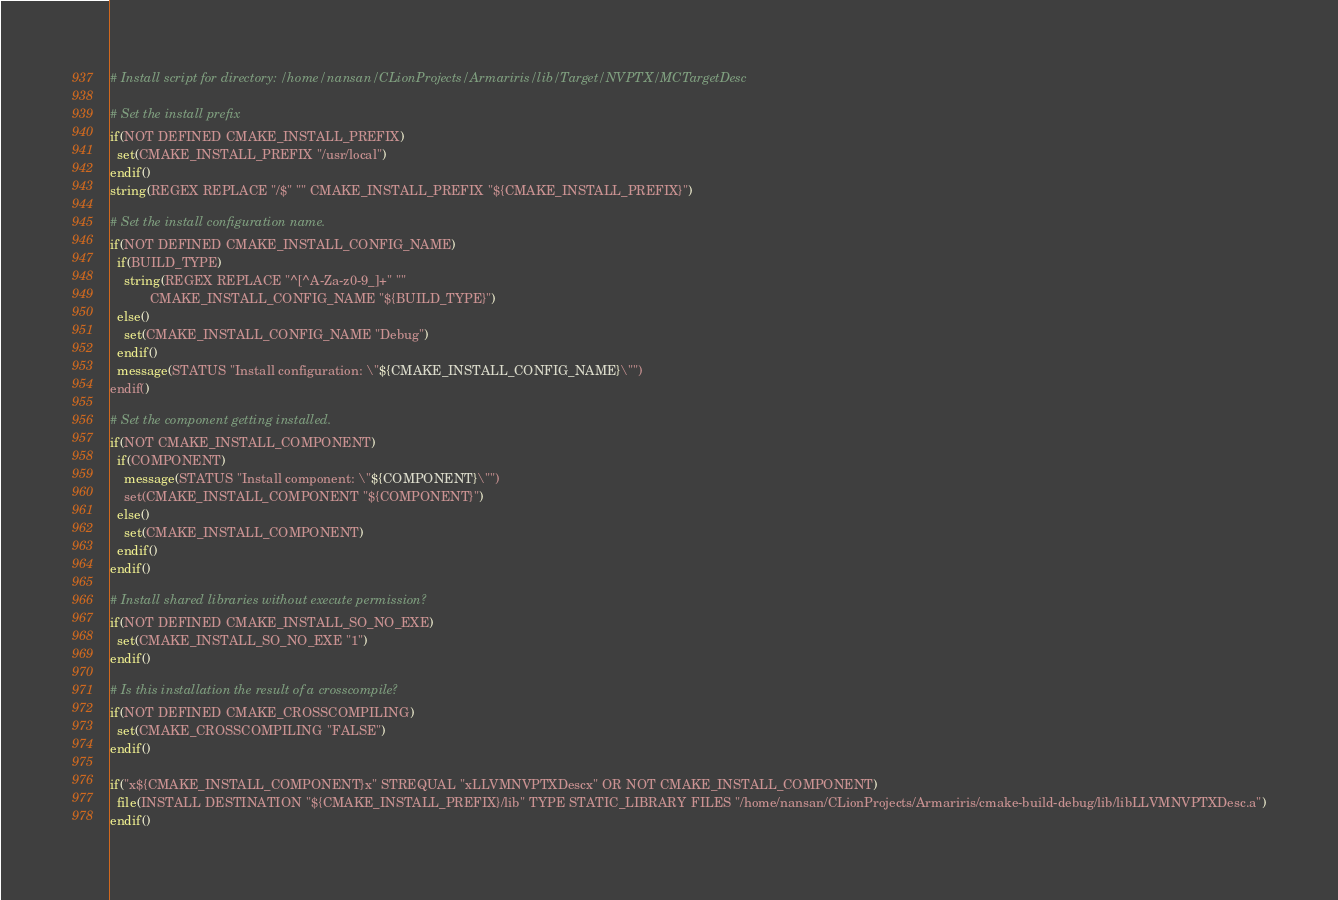<code> <loc_0><loc_0><loc_500><loc_500><_CMake_># Install script for directory: /home/nansan/CLionProjects/Armariris/lib/Target/NVPTX/MCTargetDesc

# Set the install prefix
if(NOT DEFINED CMAKE_INSTALL_PREFIX)
  set(CMAKE_INSTALL_PREFIX "/usr/local")
endif()
string(REGEX REPLACE "/$" "" CMAKE_INSTALL_PREFIX "${CMAKE_INSTALL_PREFIX}")

# Set the install configuration name.
if(NOT DEFINED CMAKE_INSTALL_CONFIG_NAME)
  if(BUILD_TYPE)
    string(REGEX REPLACE "^[^A-Za-z0-9_]+" ""
           CMAKE_INSTALL_CONFIG_NAME "${BUILD_TYPE}")
  else()
    set(CMAKE_INSTALL_CONFIG_NAME "Debug")
  endif()
  message(STATUS "Install configuration: \"${CMAKE_INSTALL_CONFIG_NAME}\"")
endif()

# Set the component getting installed.
if(NOT CMAKE_INSTALL_COMPONENT)
  if(COMPONENT)
    message(STATUS "Install component: \"${COMPONENT}\"")
    set(CMAKE_INSTALL_COMPONENT "${COMPONENT}")
  else()
    set(CMAKE_INSTALL_COMPONENT)
  endif()
endif()

# Install shared libraries without execute permission?
if(NOT DEFINED CMAKE_INSTALL_SO_NO_EXE)
  set(CMAKE_INSTALL_SO_NO_EXE "1")
endif()

# Is this installation the result of a crosscompile?
if(NOT DEFINED CMAKE_CROSSCOMPILING)
  set(CMAKE_CROSSCOMPILING "FALSE")
endif()

if("x${CMAKE_INSTALL_COMPONENT}x" STREQUAL "xLLVMNVPTXDescx" OR NOT CMAKE_INSTALL_COMPONENT)
  file(INSTALL DESTINATION "${CMAKE_INSTALL_PREFIX}/lib" TYPE STATIC_LIBRARY FILES "/home/nansan/CLionProjects/Armariris/cmake-build-debug/lib/libLLVMNVPTXDesc.a")
endif()

</code> 